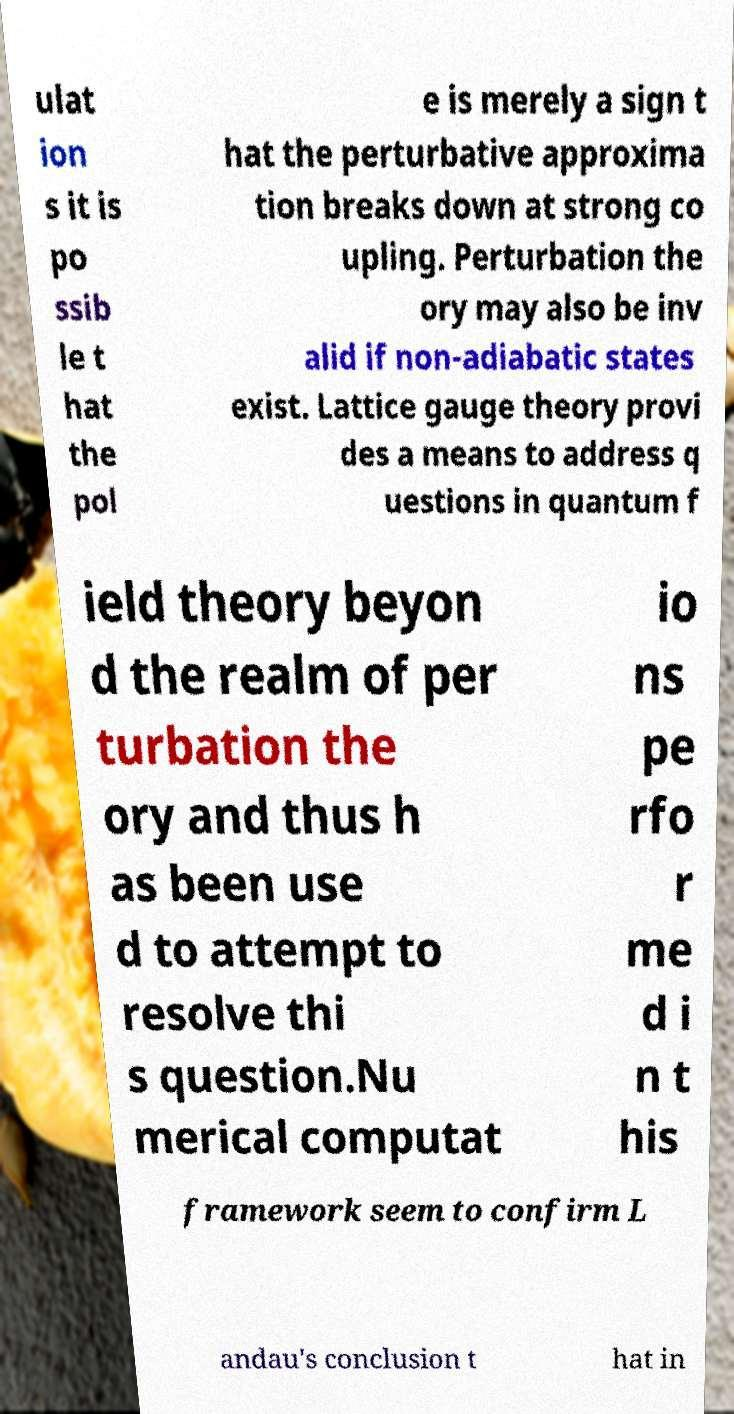Could you extract and type out the text from this image? ulat ion s it is po ssib le t hat the pol e is merely a sign t hat the perturbative approxima tion breaks down at strong co upling. Perturbation the ory may also be inv alid if non-adiabatic states exist. Lattice gauge theory provi des a means to address q uestions in quantum f ield theory beyon d the realm of per turbation the ory and thus h as been use d to attempt to resolve thi s question.Nu merical computat io ns pe rfo r me d i n t his framework seem to confirm L andau's conclusion t hat in 